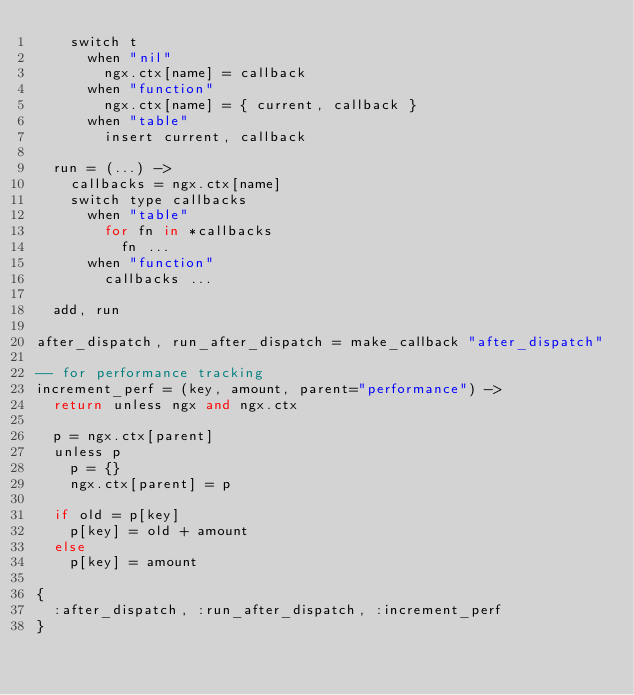Convert code to text. <code><loc_0><loc_0><loc_500><loc_500><_MoonScript_>    switch t
      when "nil"
        ngx.ctx[name] = callback
      when "function"
        ngx.ctx[name] = { current, callback }
      when "table"
        insert current, callback

  run = (...) ->
    callbacks = ngx.ctx[name]
    switch type callbacks
      when "table"
        for fn in *callbacks
          fn ...
      when "function"
        callbacks ...

  add, run

after_dispatch, run_after_dispatch = make_callback "after_dispatch"

-- for performance tracking
increment_perf = (key, amount, parent="performance") ->
  return unless ngx and ngx.ctx

  p = ngx.ctx[parent]
  unless p
    p = {}
    ngx.ctx[parent] = p

  if old = p[key]
    p[key] = old + amount
  else
    p[key] = amount

{
  :after_dispatch, :run_after_dispatch, :increment_perf
}
</code> 